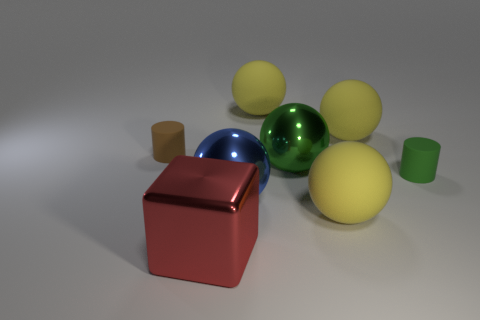Subtract all green cubes. How many yellow spheres are left? 3 Subtract all green spheres. How many spheres are left? 4 Subtract all blue spheres. How many spheres are left? 4 Add 1 blue rubber balls. How many objects exist? 9 Subtract all balls. How many objects are left? 3 Subtract all purple balls. Subtract all cyan cylinders. How many balls are left? 5 Subtract all large blue metal things. Subtract all large shiny spheres. How many objects are left? 5 Add 7 blue shiny objects. How many blue shiny objects are left? 8 Add 6 green rubber things. How many green rubber things exist? 7 Subtract 0 gray spheres. How many objects are left? 8 